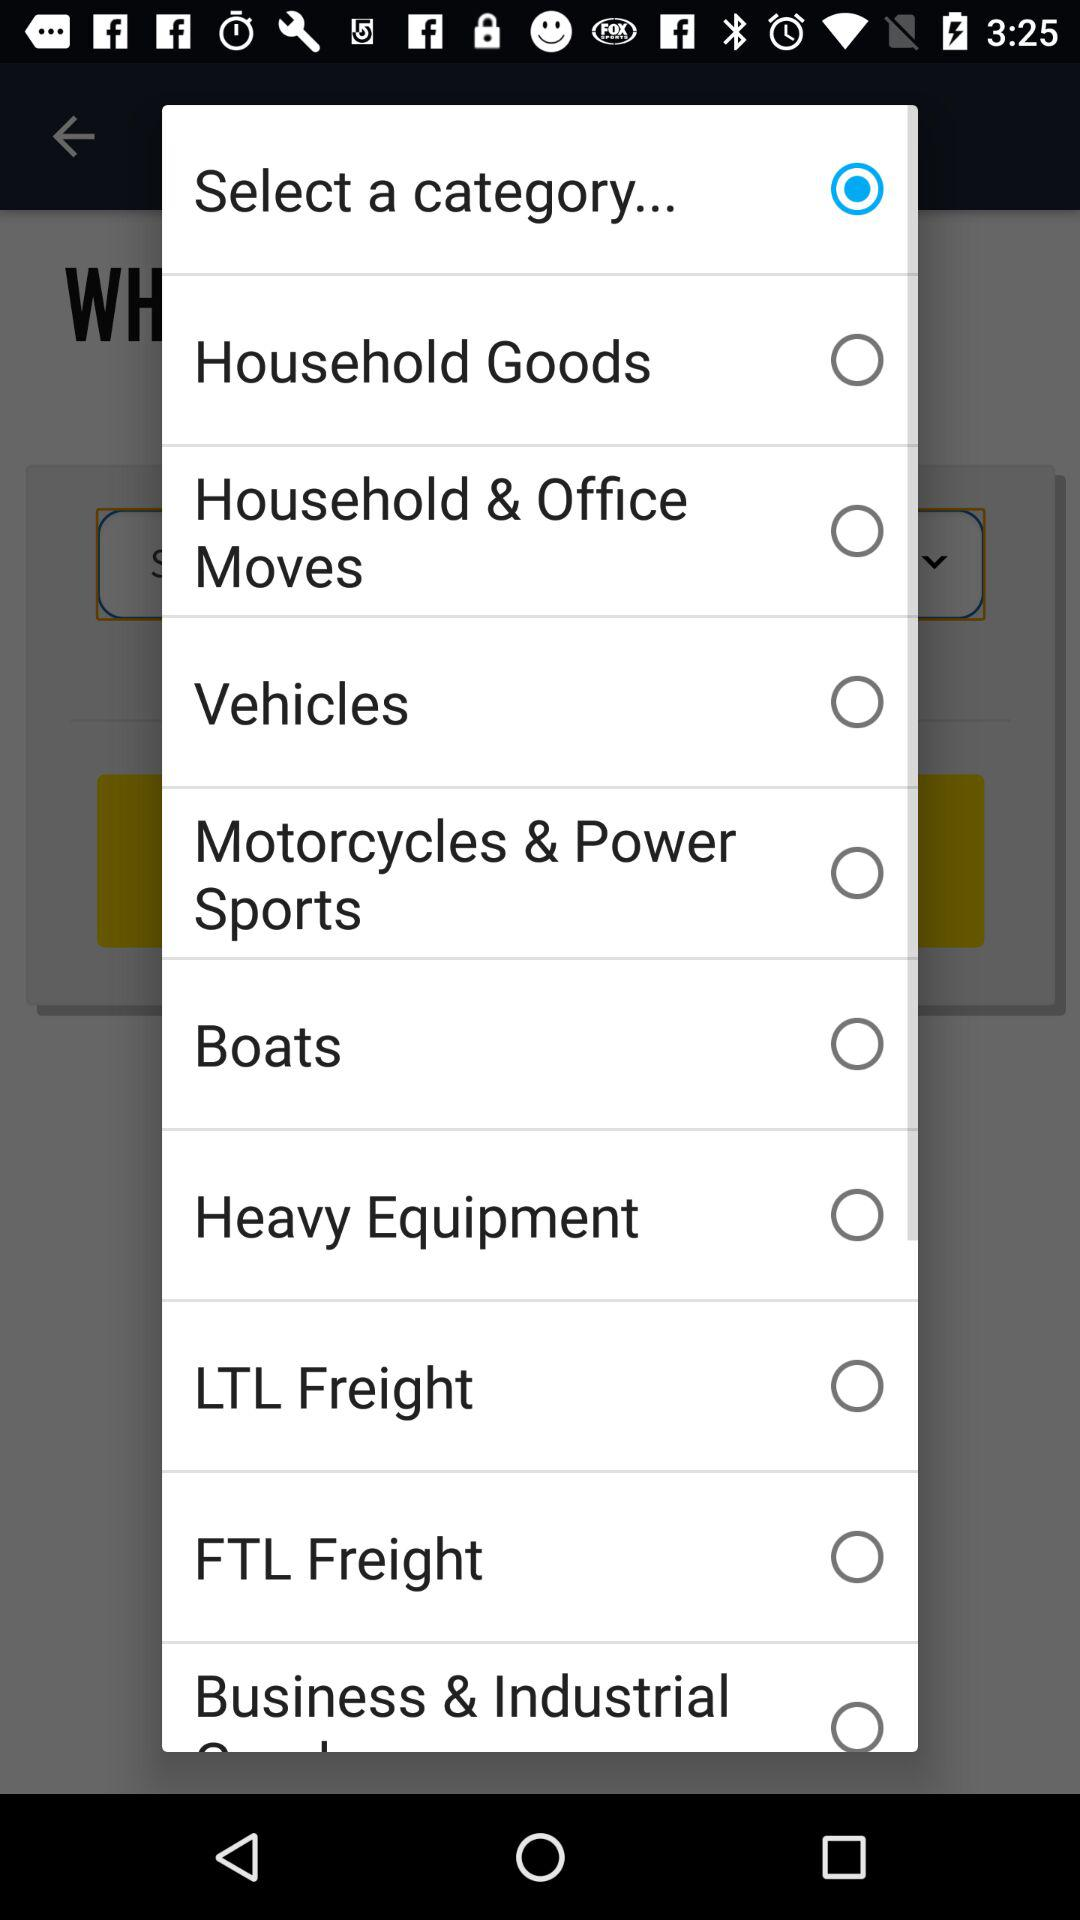What are the names of the different categories shown? The names are Household Goods, Household & Office Moves, Vehicles, Motorcycles & Power Sports, Boats, Heavy Equipment, LTL Freight, FTL Freight and Business & Industrial. 